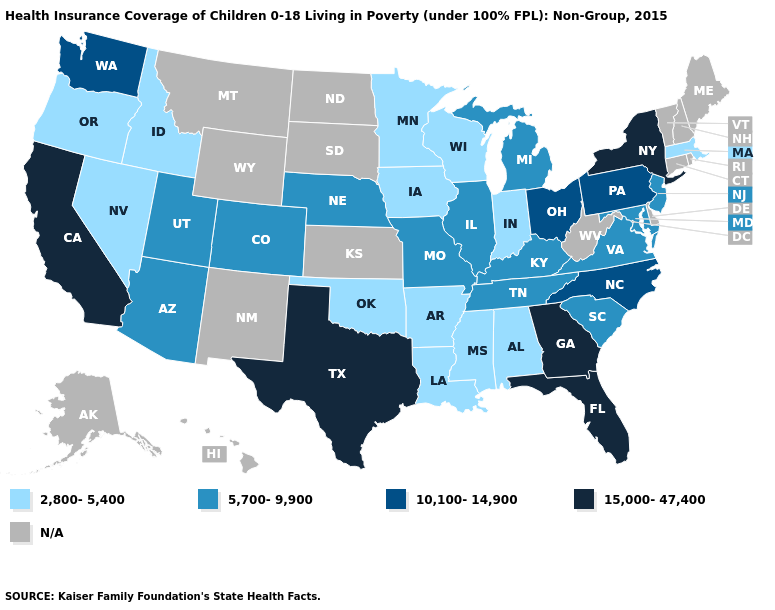What is the value of Iowa?
Keep it brief. 2,800-5,400. What is the highest value in states that border Arkansas?
Short answer required. 15,000-47,400. How many symbols are there in the legend?
Concise answer only. 5. Name the states that have a value in the range 10,100-14,900?
Keep it brief. North Carolina, Ohio, Pennsylvania, Washington. What is the value of Maine?
Concise answer only. N/A. Does the first symbol in the legend represent the smallest category?
Give a very brief answer. Yes. Among the states that border Montana , which have the highest value?
Give a very brief answer. Idaho. Name the states that have a value in the range 5,700-9,900?
Write a very short answer. Arizona, Colorado, Illinois, Kentucky, Maryland, Michigan, Missouri, Nebraska, New Jersey, South Carolina, Tennessee, Utah, Virginia. Name the states that have a value in the range 2,800-5,400?
Be succinct. Alabama, Arkansas, Idaho, Indiana, Iowa, Louisiana, Massachusetts, Minnesota, Mississippi, Nevada, Oklahoma, Oregon, Wisconsin. What is the value of Missouri?
Answer briefly. 5,700-9,900. What is the value of Wyoming?
Answer briefly. N/A. Does Georgia have the highest value in the USA?
Write a very short answer. Yes. Does Illinois have the lowest value in the MidWest?
Keep it brief. No. 